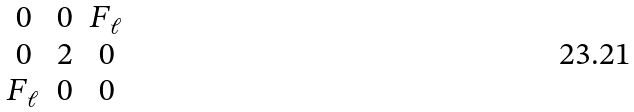Convert formula to latex. <formula><loc_0><loc_0><loc_500><loc_500>\begin{matrix} 0 & 0 & F _ { \ell } \\ 0 & 2 & 0 \\ F _ { \ell } & 0 & 0 \end{matrix}</formula> 